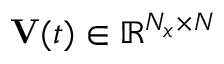Convert formula to latex. <formula><loc_0><loc_0><loc_500><loc_500>V ( t ) \in \mathbb { R } ^ { N _ { x } \times N }</formula> 